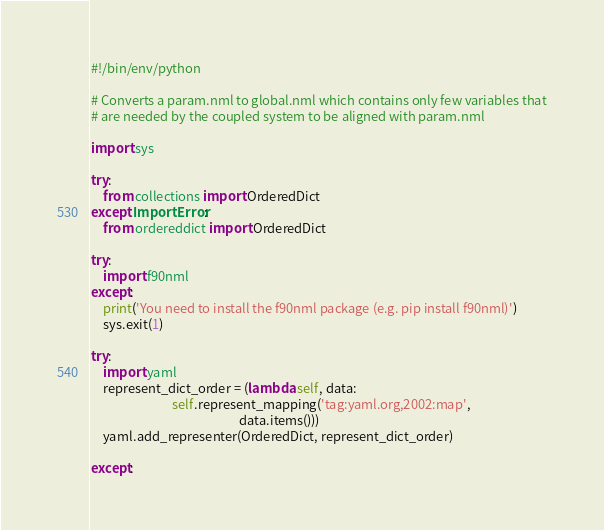<code> <loc_0><loc_0><loc_500><loc_500><_Python_>#!/bin/env/python

# Converts a param.nml to global.nml which contains only few variables that
# are needed by the coupled system to be aligned with param.nml

import sys

try:
    from collections import OrderedDict
except ImportError:
    from ordereddict import OrderedDict

try:
    import f90nml
except:
    print('You need to install the f90nml package (e.g. pip install f90nml)')
    sys.exit(1)

try:
    import yaml
    represent_dict_order = (lambda self, data:
                            self.represent_mapping('tag:yaml.org,2002:map',
                                                   data.items()))
    yaml.add_representer(OrderedDict, represent_dict_order)

except:</code> 